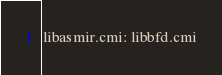Convert code to text. <code><loc_0><loc_0><loc_500><loc_500><_D_>libasmir.cmi: libbfd.cmi
</code> 